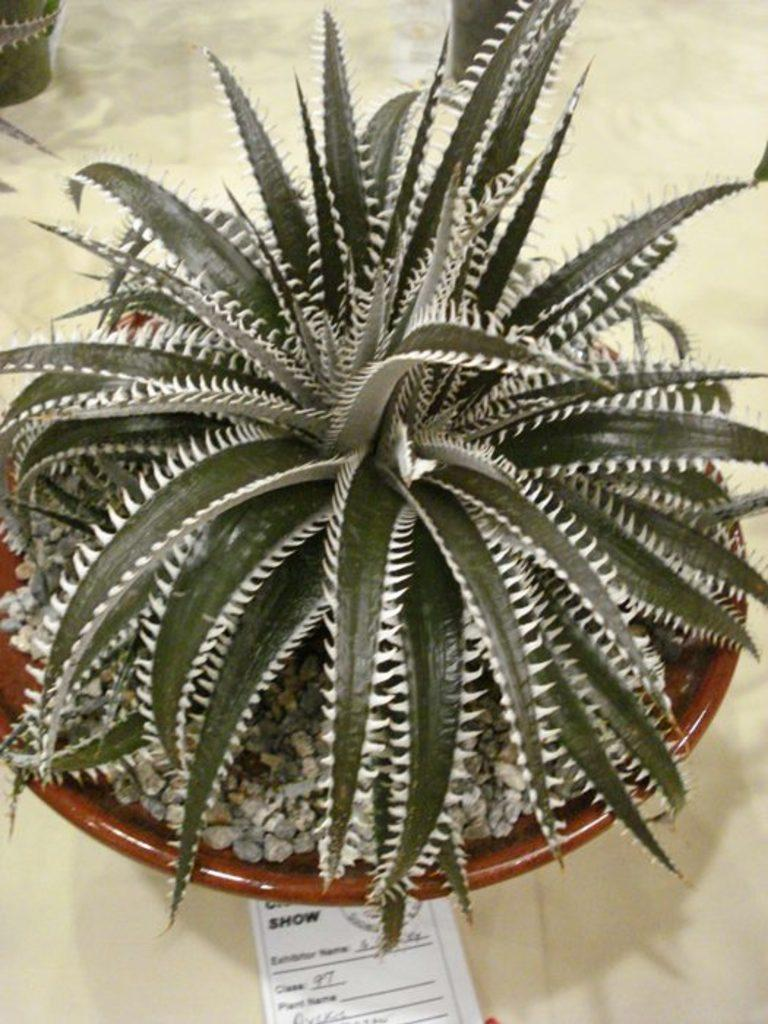What type of plant is in the image? There is a house plant in the image. Where is the house plant located in the image? The house plant is in the center of the image. On what surface is the house plant placed? The house plant is placed on a table. What type of prose is the house plant reciting in the image? There is no indication in the image that the house plant is reciting any prose, as plants do not have the ability to speak or recite literature. 